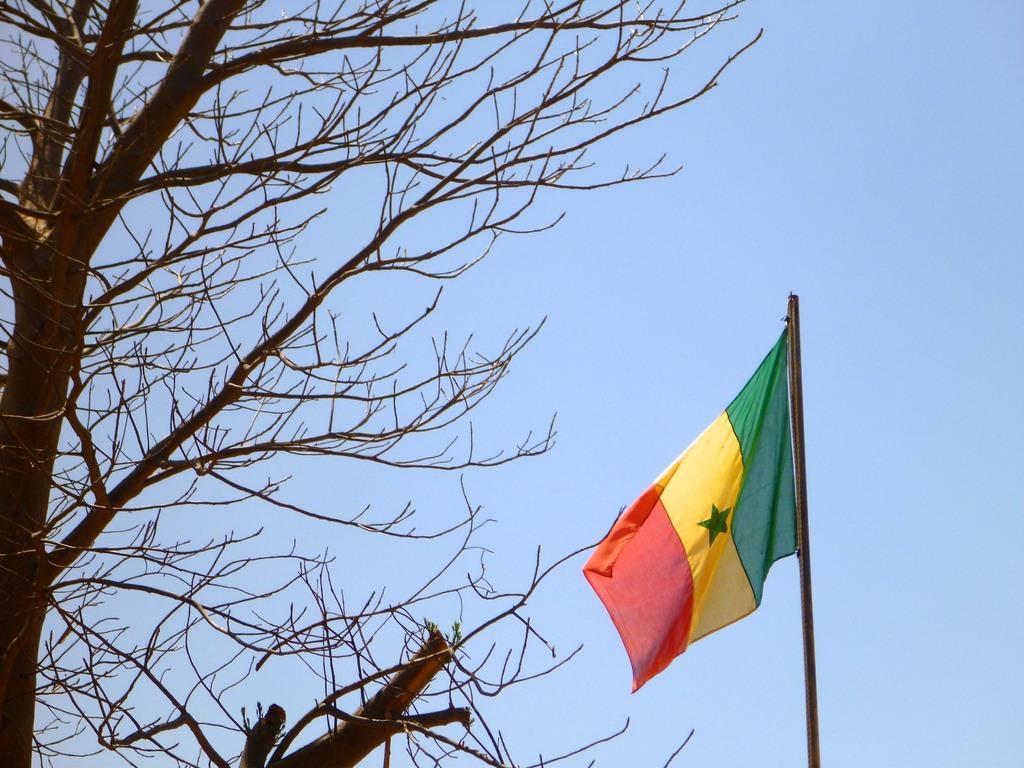How would you summarize this image in a sentence or two? In this picture we can see a tree and flag pole. In the background of the image we can see the sky. 